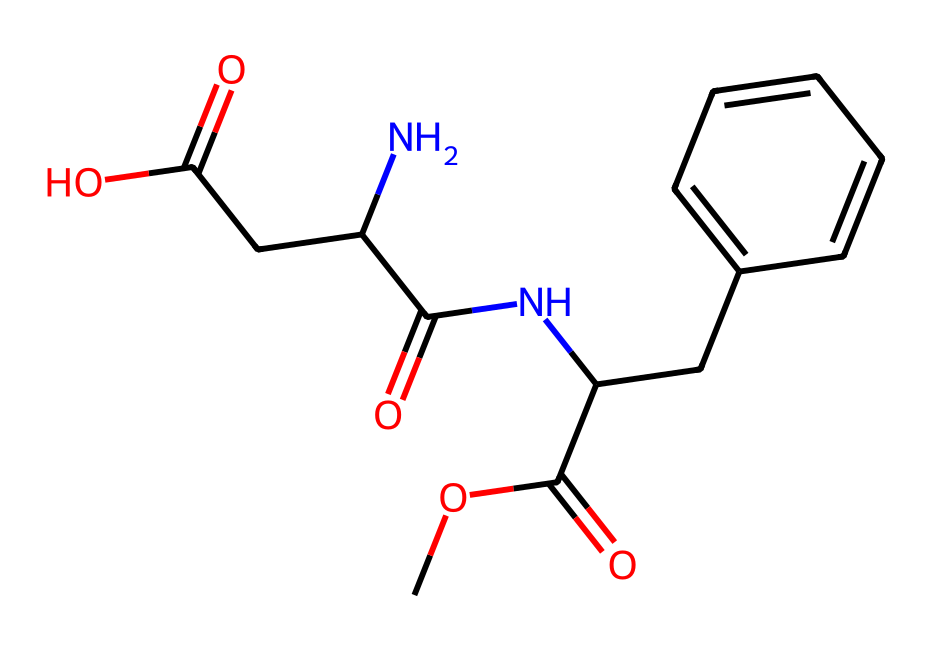What is the molecular formula of this chemical? To determine the molecular formula, count the number of each type of atom in the SMILES representation. The atoms present are Carbon (C), Hydrogen (H), Nitrogen (N), and Oxygen (O). After analyzing, the formula is C14H17N2O4.
Answer: C14H17N2O4 How many nitrogen atoms are in this chemical? By analyzing the SMILES representation, we can see that there are two occurrences of the nitrogen atom (N) in the structure.
Answer: 2 What is the primary functional group present? The most prominent functional groups can be identified as the amide (NC=O) and carboxylic acid (C(=O)O) due to their defining graphical structure. Given their importance in food additives, the amide group is primary in this compound.
Answer: amide Does this chemical contain any aromatic rings? Upon examining the structure, there is a benzene ring indicated by the presence of alternating double bonds, which confirms the presence of aromaticity in a section of the molecule.
Answer: Yes Is this compound likely to be sweet-tasting? The presence of amides and specific arrangements of carbon and nitrogen in the SMILES suggest properties that are commonly associated with sweeteners, indicating a likelihood of sweetness.
Answer: Likely How many carbon atoms are involved in the aromatic ring? By examining the representation, the aromatic ring is attached to the main chain and consists of six carbon atoms as indicated by the cyclic structure with alternating double bonds.
Answer: 6 